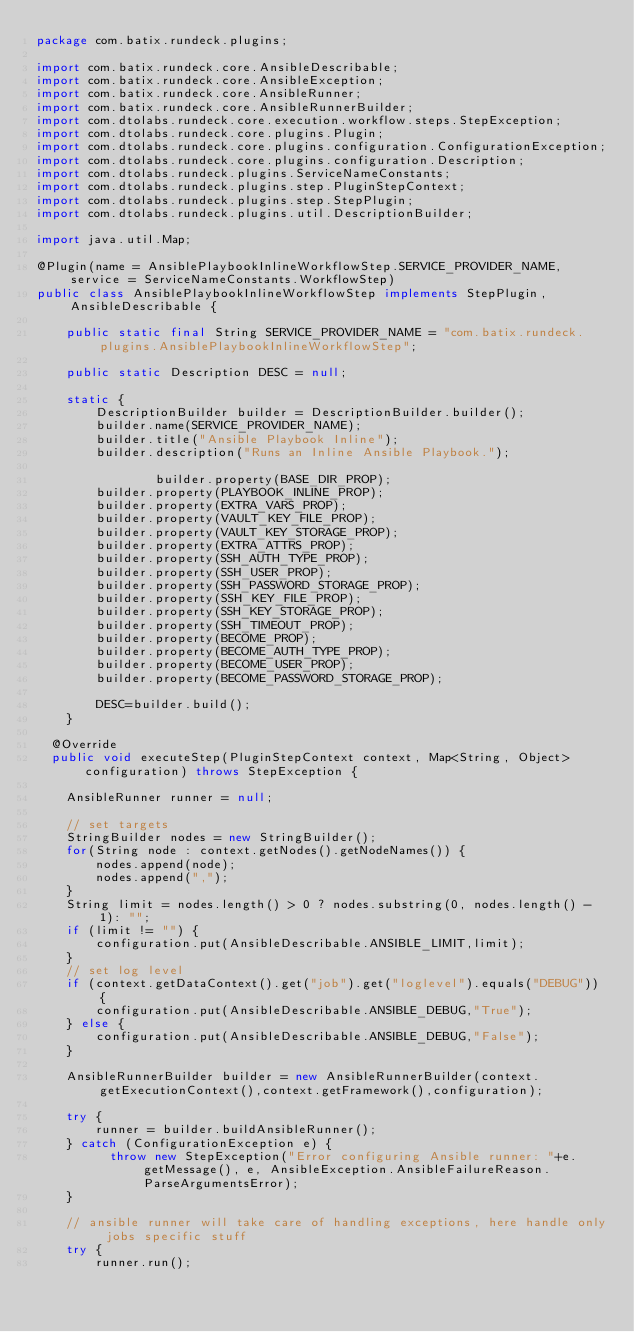<code> <loc_0><loc_0><loc_500><loc_500><_Java_>package com.batix.rundeck.plugins;

import com.batix.rundeck.core.AnsibleDescribable;
import com.batix.rundeck.core.AnsibleException;
import com.batix.rundeck.core.AnsibleRunner;
import com.batix.rundeck.core.AnsibleRunnerBuilder;
import com.dtolabs.rundeck.core.execution.workflow.steps.StepException;
import com.dtolabs.rundeck.core.plugins.Plugin;
import com.dtolabs.rundeck.core.plugins.configuration.ConfigurationException;
import com.dtolabs.rundeck.core.plugins.configuration.Description;
import com.dtolabs.rundeck.plugins.ServiceNameConstants;
import com.dtolabs.rundeck.plugins.step.PluginStepContext;
import com.dtolabs.rundeck.plugins.step.StepPlugin;
import com.dtolabs.rundeck.plugins.util.DescriptionBuilder;

import java.util.Map;

@Plugin(name = AnsiblePlaybookInlineWorkflowStep.SERVICE_PROVIDER_NAME, service = ServiceNameConstants.WorkflowStep)
public class AnsiblePlaybookInlineWorkflowStep implements StepPlugin, AnsibleDescribable {

	public static final String SERVICE_PROVIDER_NAME = "com.batix.rundeck.plugins.AnsiblePlaybookInlineWorkflowStep";

	public static Description DESC = null;

    static {
        DescriptionBuilder builder = DescriptionBuilder.builder();
        builder.name(SERVICE_PROVIDER_NAME);
        builder.title("Ansible Playbook Inline");
        builder.description("Runs an Inline Ansible Playbook.");

				builder.property(BASE_DIR_PROP);
        builder.property(PLAYBOOK_INLINE_PROP);
        builder.property(EXTRA_VARS_PROP);
        builder.property(VAULT_KEY_FILE_PROP);
        builder.property(VAULT_KEY_STORAGE_PROP);
        builder.property(EXTRA_ATTRS_PROP);
        builder.property(SSH_AUTH_TYPE_PROP);
        builder.property(SSH_USER_PROP);
        builder.property(SSH_PASSWORD_STORAGE_PROP);
        builder.property(SSH_KEY_FILE_PROP);
        builder.property(SSH_KEY_STORAGE_PROP);
        builder.property(SSH_TIMEOUT_PROP);
        builder.property(BECOME_PROP);
        builder.property(BECOME_AUTH_TYPE_PROP);
        builder.property(BECOME_USER_PROP);
        builder.property(BECOME_PASSWORD_STORAGE_PROP);

        DESC=builder.build();
    }

  @Override
  public void executeStep(PluginStepContext context, Map<String, Object> configuration) throws StepException {

    AnsibleRunner runner = null;

    // set targets
    StringBuilder nodes = new StringBuilder();
    for(String node : context.getNodes().getNodeNames()) {
    	nodes.append(node);
    	nodes.append(",");
    }
    String limit = nodes.length() > 0 ? nodes.substring(0, nodes.length() - 1): "";
    if (limit != "") {
        configuration.put(AnsibleDescribable.ANSIBLE_LIMIT,limit);
    }
    // set log level
    if (context.getDataContext().get("job").get("loglevel").equals("DEBUG")) {
        configuration.put(AnsibleDescribable.ANSIBLE_DEBUG,"True");
    } else {
        configuration.put(AnsibleDescribable.ANSIBLE_DEBUG,"False");
    }

    AnsibleRunnerBuilder builder = new AnsibleRunnerBuilder(context.getExecutionContext(),context.getFramework(),configuration);

    try {
        runner = builder.buildAnsibleRunner();
    } catch (ConfigurationException e) {
          throw new StepException("Error configuring Ansible runner: "+e.getMessage(), e, AnsibleException.AnsibleFailureReason.ParseArgumentsError);
    }

    // ansible runner will take care of handling exceptions, here handle only jobs specific stuff
    try {
        runner.run();</code> 